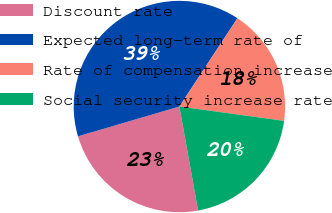Convert chart to OTSL. <chart><loc_0><loc_0><loc_500><loc_500><pie_chart><fcel>Discount rate<fcel>Expected long-term rate of<fcel>Rate of compensation increase<fcel>Social security increase rate<nl><fcel>23.28%<fcel>38.81%<fcel>17.91%<fcel>20.0%<nl></chart> 